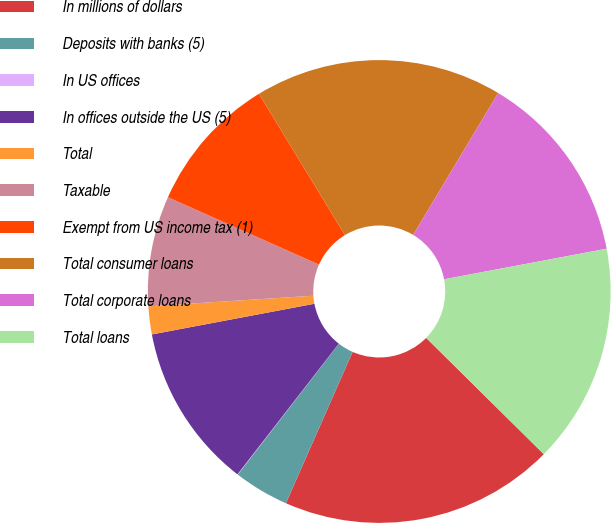<chart> <loc_0><loc_0><loc_500><loc_500><pie_chart><fcel>In millions of dollars<fcel>Deposits with banks (5)<fcel>In US offices<fcel>In offices outside the US (5)<fcel>Total<fcel>Taxable<fcel>Exempt from US income tax (1)<fcel>Total consumer loans<fcel>Total corporate loans<fcel>Total loans<nl><fcel>19.2%<fcel>3.86%<fcel>0.03%<fcel>11.53%<fcel>1.95%<fcel>7.7%<fcel>9.62%<fcel>17.29%<fcel>13.45%<fcel>15.37%<nl></chart> 